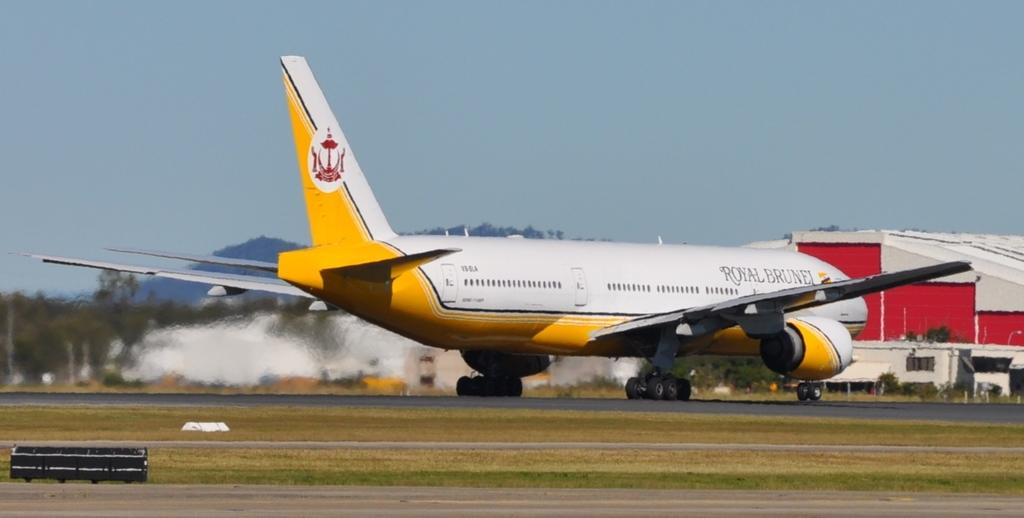<image>
Summarize the visual content of the image. a plane that has the word royal on the side 